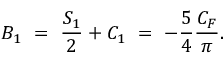Convert formula to latex. <formula><loc_0><loc_0><loc_500><loc_500>B _ { 1 } = \frac { S _ { 1 } } { 2 } + C _ { 1 } = - \frac { 5 } { 4 } \frac { C _ { F } } { \pi } .</formula> 